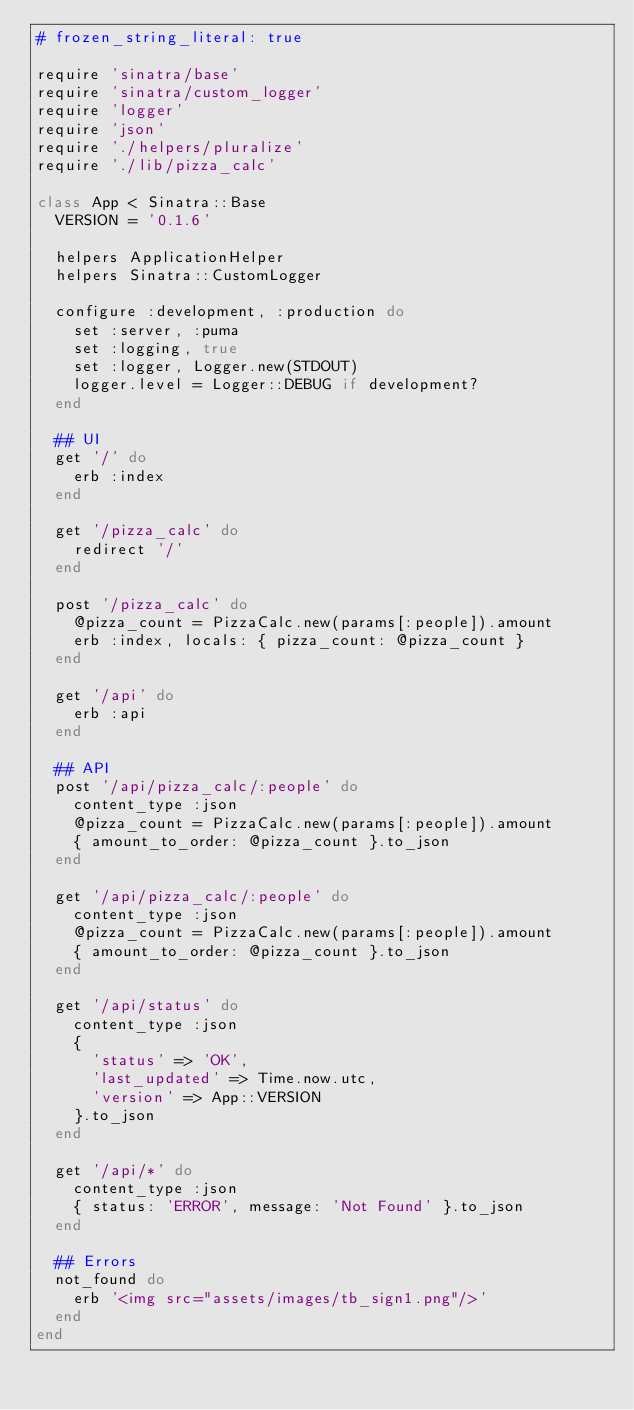<code> <loc_0><loc_0><loc_500><loc_500><_Ruby_># frozen_string_literal: true

require 'sinatra/base'
require 'sinatra/custom_logger'
require 'logger'
require 'json'
require './helpers/pluralize'
require './lib/pizza_calc'

class App < Sinatra::Base
  VERSION = '0.1.6'

  helpers ApplicationHelper
  helpers Sinatra::CustomLogger

  configure :development, :production do
    set :server, :puma
    set :logging, true
    set :logger, Logger.new(STDOUT)
    logger.level = Logger::DEBUG if development?
  end

  ## UI
  get '/' do
    erb :index
  end

  get '/pizza_calc' do
    redirect '/'
  end

  post '/pizza_calc' do
    @pizza_count = PizzaCalc.new(params[:people]).amount
    erb :index, locals: { pizza_count: @pizza_count }
  end

  get '/api' do
    erb :api
  end

  ## API
  post '/api/pizza_calc/:people' do
    content_type :json
    @pizza_count = PizzaCalc.new(params[:people]).amount
    { amount_to_order: @pizza_count }.to_json
  end

  get '/api/pizza_calc/:people' do
    content_type :json
    @pizza_count = PizzaCalc.new(params[:people]).amount
    { amount_to_order: @pizza_count }.to_json
  end

  get '/api/status' do
    content_type :json
    {
      'status' => 'OK',
      'last_updated' => Time.now.utc,
      'version' => App::VERSION
    }.to_json
  end

  get '/api/*' do
    content_type :json
    { status: 'ERROR', message: 'Not Found' }.to_json
  end

  ## Errors
  not_found do
    erb '<img src="assets/images/tb_sign1.png"/>'
  end
end
</code> 